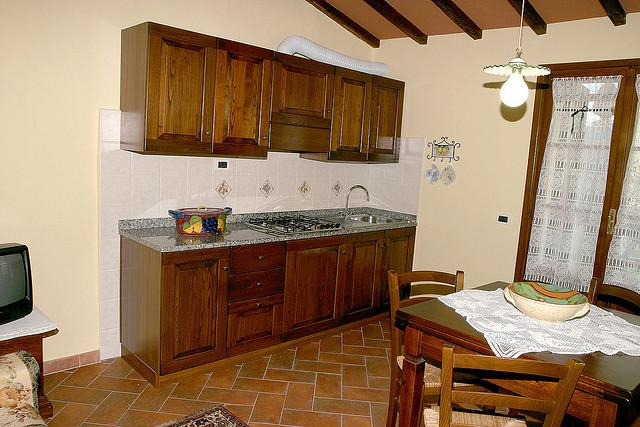What is the white tube on top of the cabinet used for?

Choices:
A) heating
B) ventilation
C) air conditioning
D) water ventilation 